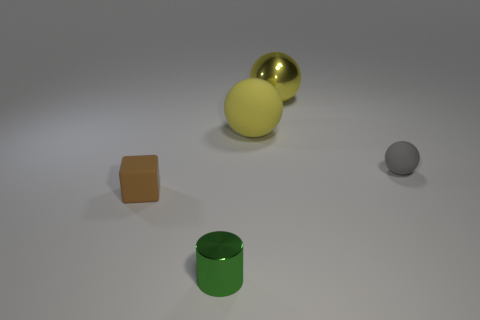Subtract all matte balls. How many balls are left? 1 Subtract all red cylinders. How many yellow spheres are left? 2 Subtract 1 balls. How many balls are left? 2 Add 3 tiny brown matte blocks. How many objects exist? 8 Subtract all cubes. How many objects are left? 4 Subtract all big red cubes. Subtract all yellow shiny balls. How many objects are left? 4 Add 2 large metallic things. How many large metallic things are left? 3 Add 5 gray metal spheres. How many gray metal spheres exist? 5 Subtract 0 gray cubes. How many objects are left? 5 